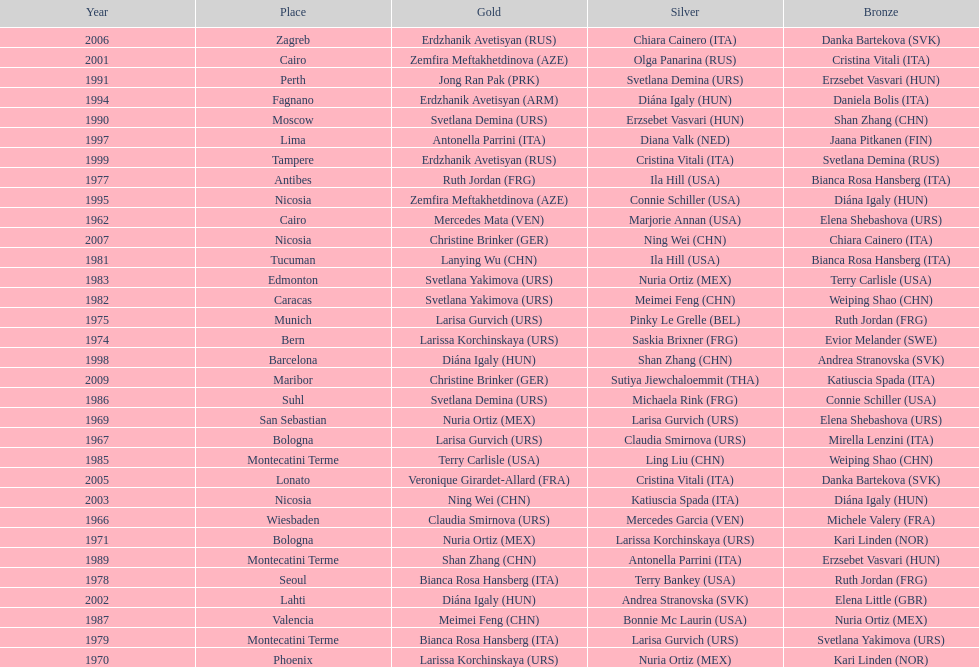What is the total of silver for cairo 0. 